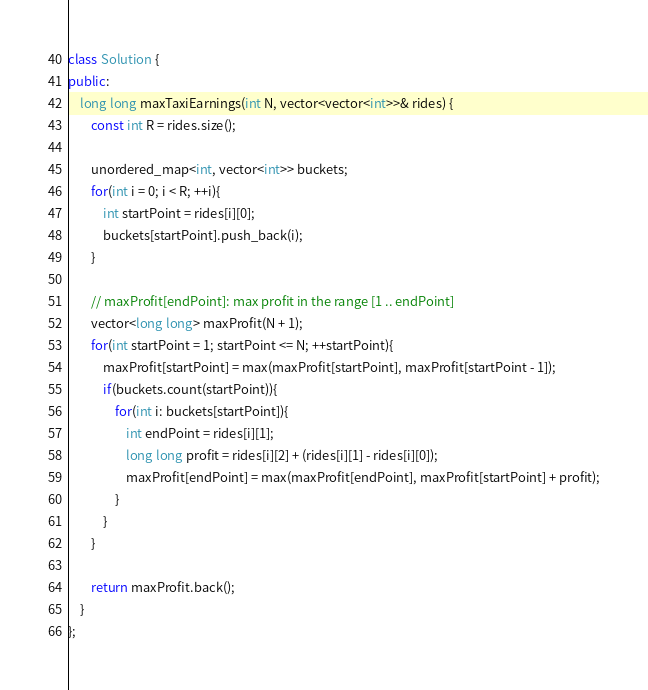<code> <loc_0><loc_0><loc_500><loc_500><_C++_>class Solution {
public:
    long long maxTaxiEarnings(int N, vector<vector<int>>& rides) {
        const int R = rides.size();
        
        unordered_map<int, vector<int>> buckets;
        for(int i = 0; i < R; ++i){
            int startPoint = rides[i][0];
            buckets[startPoint].push_back(i);
        }
        
        // maxProfit[endPoint]: max profit in the range [1 .. endPoint]
        vector<long long> maxProfit(N + 1);
        for(int startPoint = 1; startPoint <= N; ++startPoint){
            maxProfit[startPoint] = max(maxProfit[startPoint], maxProfit[startPoint - 1]);
            if(buckets.count(startPoint)){
                for(int i: buckets[startPoint]){
                    int endPoint = rides[i][1];
                    long long profit = rides[i][2] + (rides[i][1] - rides[i][0]);
                    maxProfit[endPoint] = max(maxProfit[endPoint], maxProfit[startPoint] + profit);
                }
            }
        }
        
        return maxProfit.back();
    }
};</code> 